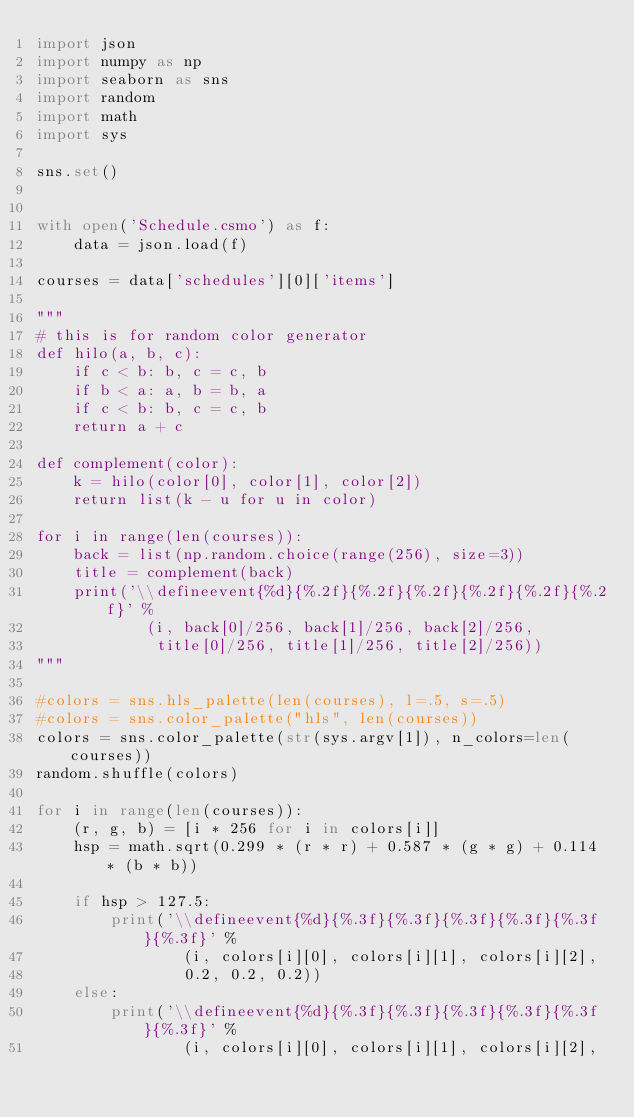Convert code to text. <code><loc_0><loc_0><loc_500><loc_500><_Python_>import json
import numpy as np
import seaborn as sns
import random
import math
import sys

sns.set()


with open('Schedule.csmo') as f:
    data = json.load(f)

courses = data['schedules'][0]['items']

"""
# this is for random color generator
def hilo(a, b, c):
    if c < b: b, c = c, b
    if b < a: a, b = b, a
    if c < b: b, c = c, b
    return a + c

def complement(color):
    k = hilo(color[0], color[1], color[2])
    return list(k - u for u in color)

for i in range(len(courses)):
    back = list(np.random.choice(range(256), size=3))
    title = complement(back)
    print('\\defineevent{%d}{%.2f}{%.2f}{%.2f}{%.2f}{%.2f}{%.2f}' %
            (i, back[0]/256, back[1]/256, back[2]/256,
             title[0]/256, title[1]/256, title[2]/256))
"""

#colors = sns.hls_palette(len(courses), l=.5, s=.5)
#colors = sns.color_palette("hls", len(courses))
colors = sns.color_palette(str(sys.argv[1]), n_colors=len(courses))
random.shuffle(colors)

for i in range(len(courses)):
    (r, g, b) = [i * 256 for i in colors[i]]
    hsp = math.sqrt(0.299 * (r * r) + 0.587 * (g * g) + 0.114 * (b * b))

    if hsp > 127.5:
        print('\\defineevent{%d}{%.3f}{%.3f}{%.3f}{%.3f}{%.3f}{%.3f}' %
                (i, colors[i][0], colors[i][1], colors[i][2],
                0.2, 0.2, 0.2))
    else:
        print('\\defineevent{%d}{%.3f}{%.3f}{%.3f}{%.3f}{%.3f}{%.3f}' %
                (i, colors[i][0], colors[i][1], colors[i][2],</code> 